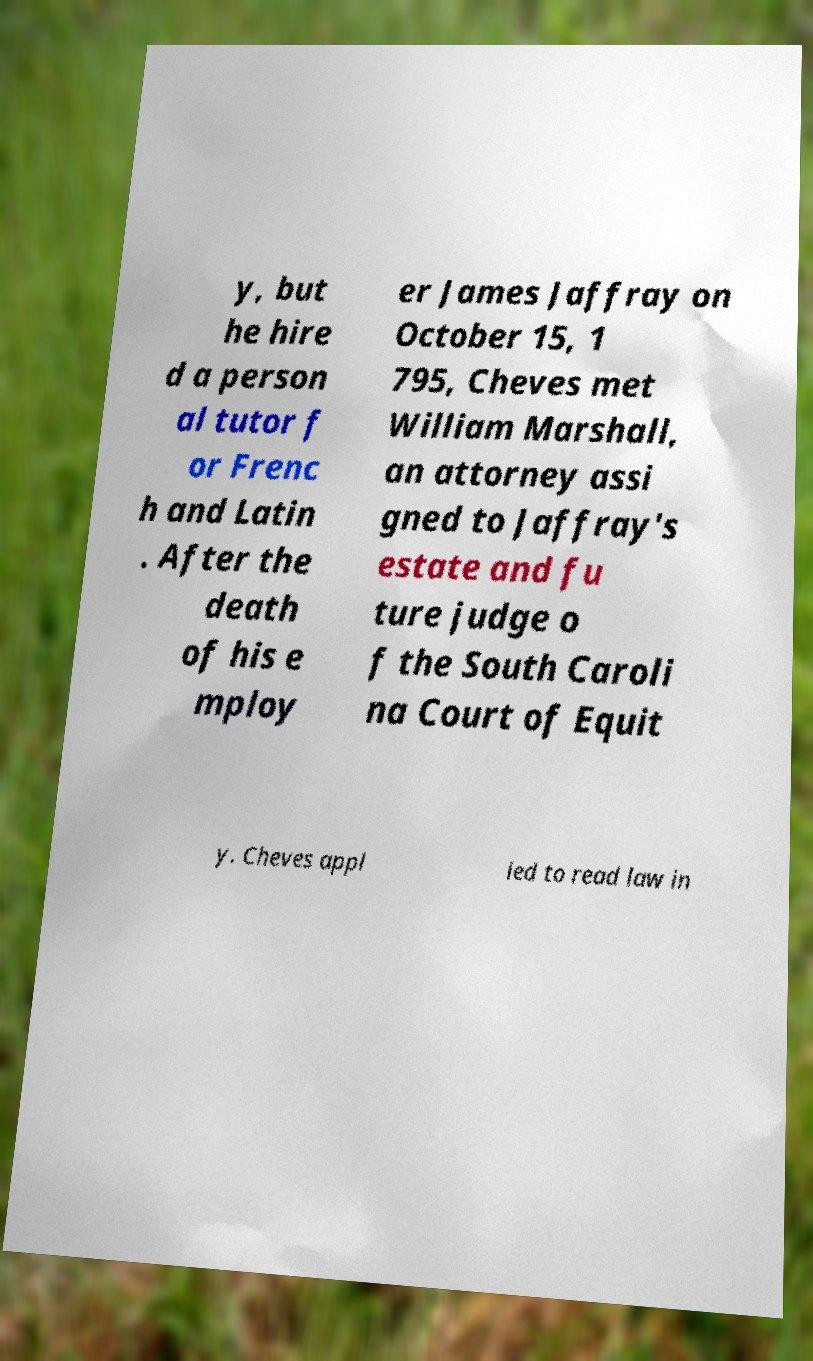For documentation purposes, I need the text within this image transcribed. Could you provide that? y, but he hire d a person al tutor f or Frenc h and Latin . After the death of his e mploy er James Jaffray on October 15, 1 795, Cheves met William Marshall, an attorney assi gned to Jaffray's estate and fu ture judge o f the South Caroli na Court of Equit y. Cheves appl ied to read law in 